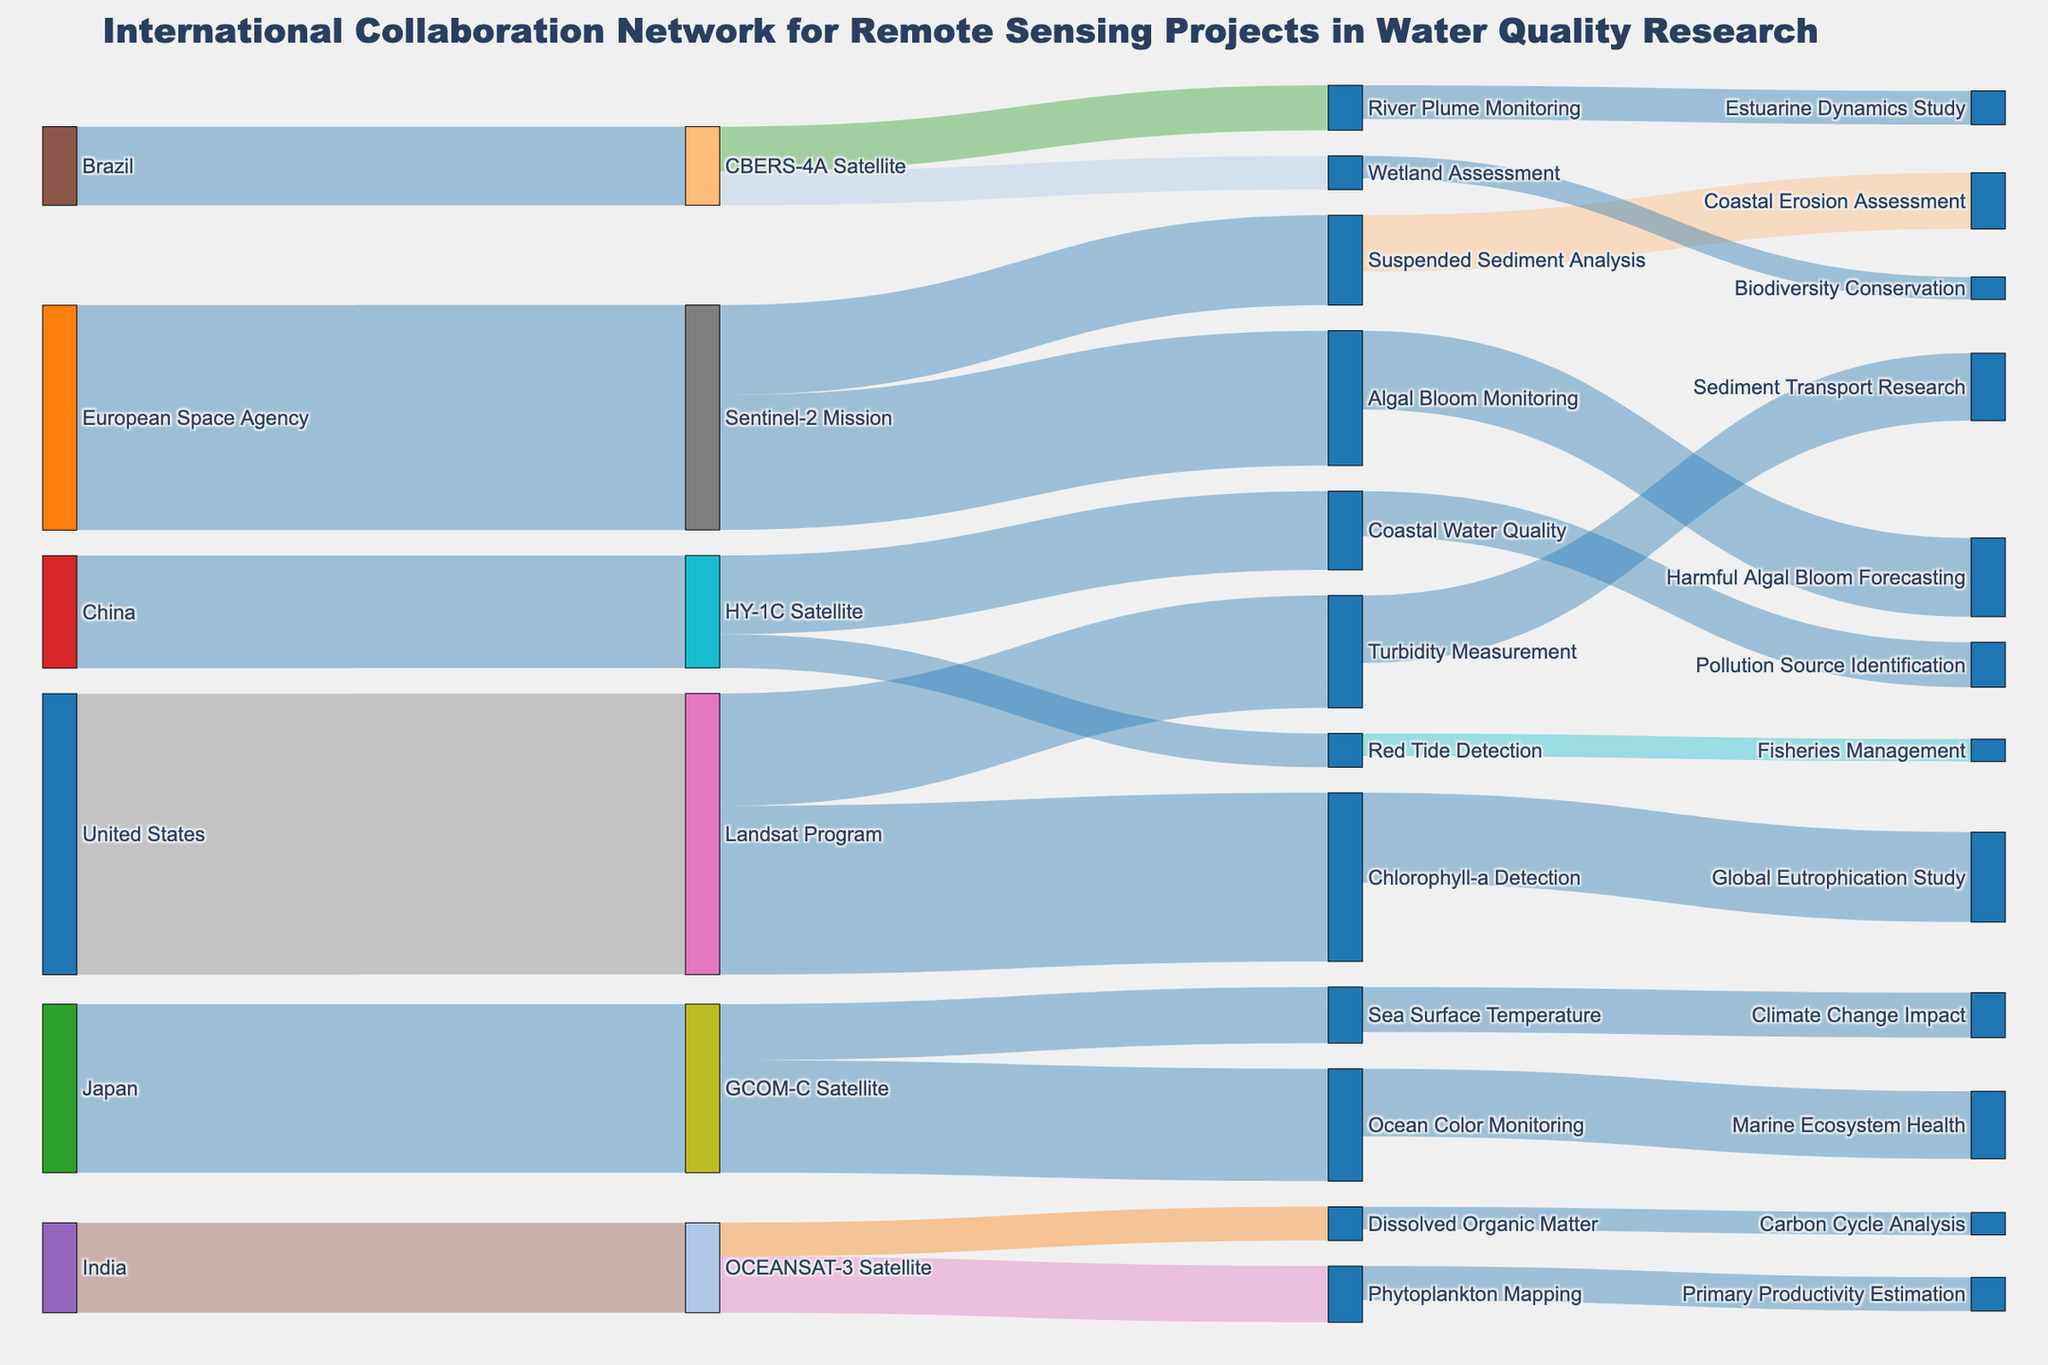What's the title of the figure? The title of the figure is usually displayed prominently at the top. Here, the title is given as "International Collaboration Network for Remote Sensing Projects in Water Quality Research."
Answer: International Collaboration Network for Remote Sensing Projects in Water Quality Research How many countries are involved in the collaboration network? To determine the number of countries involved, count the distinct source labels that are country names in the data. These are "United States," "European Space Agency," "Japan," "China," "India," and "Brazil."
Answer: 6 Which satellite mission involves the highest value of collaboration in the network? To find the satellite mission with the highest value, look for the target node with the largest value associated with it. "Landsat Program" has the highest value of 25.
Answer: Landsat Program What is the combined collaboration value of the United States and China? To find the combined value, add the collaboration values associated with the United States and China. The United States has a value of 25, and China has a value of 10. So, 25 + 10 = 35.
Answer: 35 How many research areas are monitored by Sentinel-2 Mission? To find this, count the target nodes directly linked from "Sentinel-2 Mission." These nodes are "Algal Bloom Monitoring" and "Suspended Sediment Analysis," which totals to 2.
Answer: 2 Which country contributes to Red Tide Detection? Look for the source node associated with the target node "Red Tide Detection." Based on the data, "China" contributes to "Red Tide Detection."
Answer: China What is the total value associated with water quality monitoring in India? India contributes collaboration values to "Phytoplankton Mapping" (5) and "Dissolved Organic Matter" (3). Summing these values, 5 + 3 = 8.
Answer: 8 Compare the collaboration values of Japan's GCOM-C Satellite for Ocean Color Monitoring and Sea Surface Temperature. Which one is higher? Look at the collaboration values associated with Japan's GCOM-C Satellite. For Ocean Color Monitoring, the value is 10, and for Sea Surface Temperature, it's 5. 10 is higher than 5.
Answer: Ocean Color Monitoring Identify the research area that has a link to Climate Change Impact. Follow the link associated with "Climate Change Impact" to find the previous node. The link starts from "Sea Surface Temperature."
Answer: Sea Surface Temperature Calculate the total collaboration value for all branches of the Landsat Program. Sum up the collaboration values linked to the Landsat Program: Chlorophyll-a Detection (15) and Turbidity Measurement (10). So, 15 + 10 = 25.
Answer: 25 